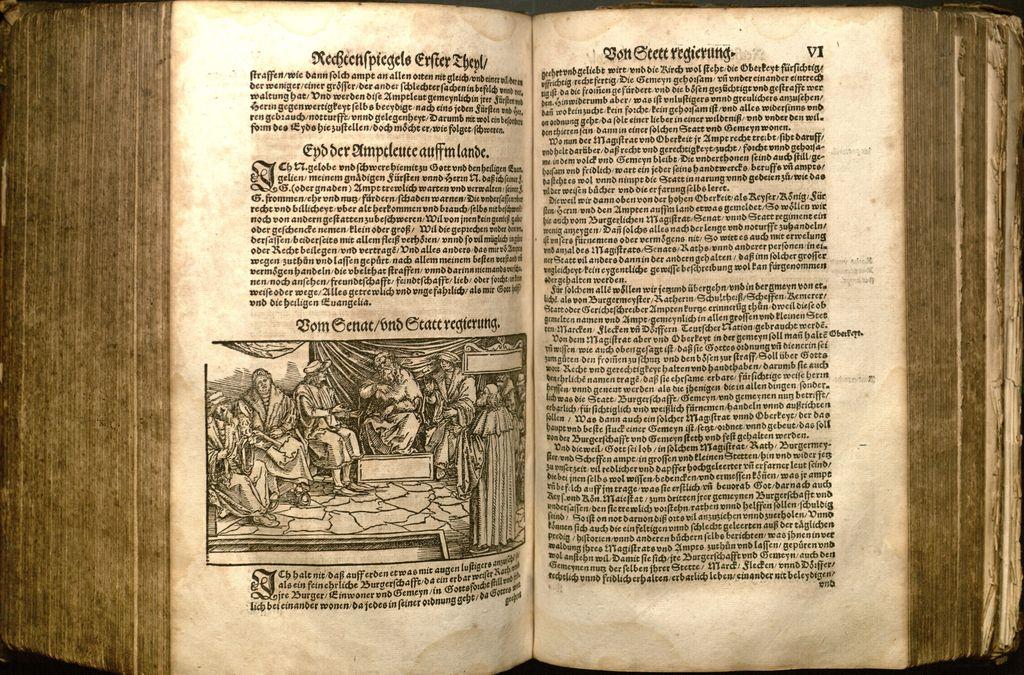What page is the rightmost page in the top right corner?
Provide a succinct answer. Vi. 